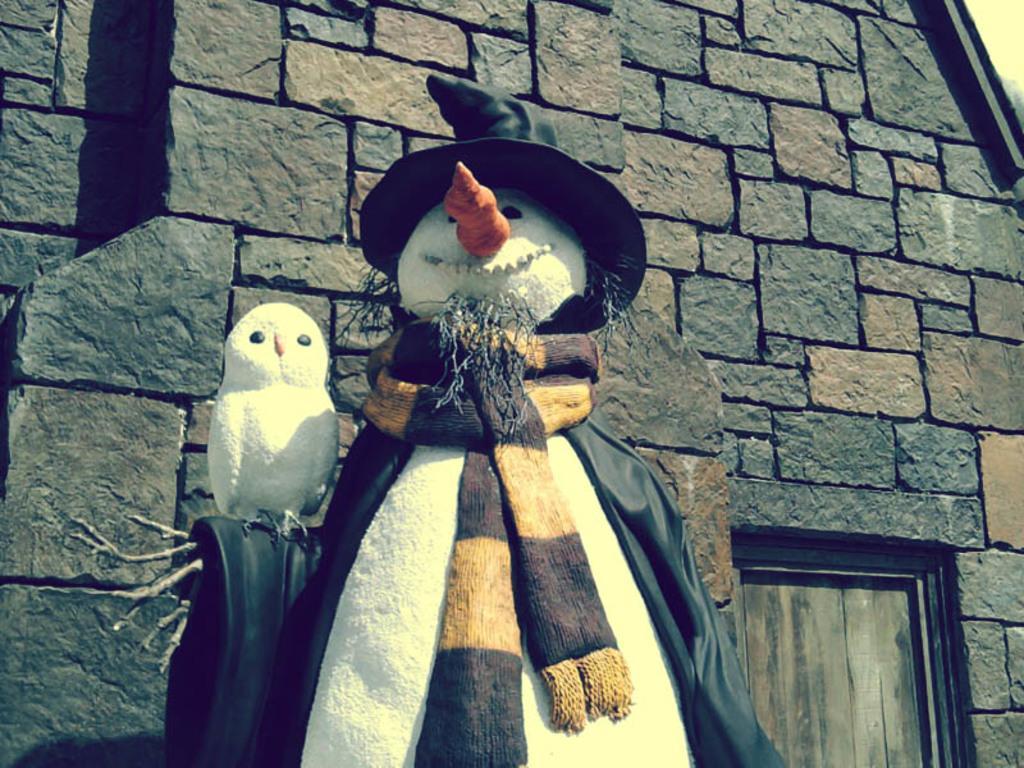Can you describe this image briefly? In this picture we can see a snowman, a snowbird, scarf, coat, hat and branches. Behind the snowman there is a door and a house. 